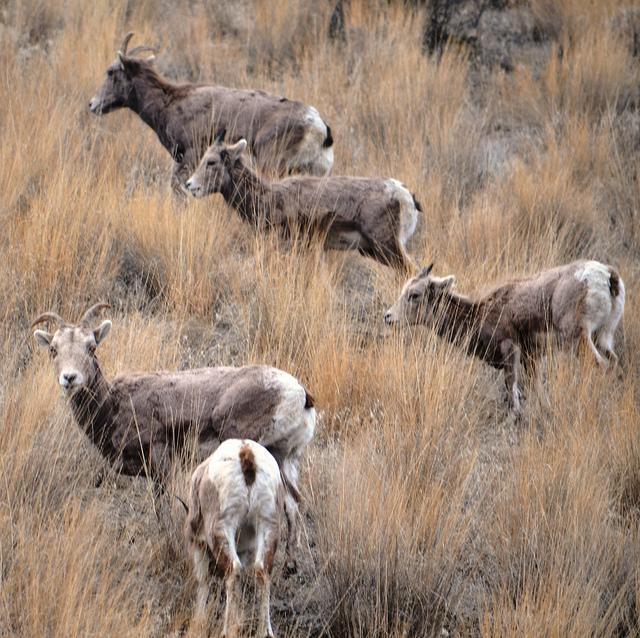How many goats are in this scene?
Give a very brief answer. 5. How many sheep are there?
Give a very brief answer. 5. 